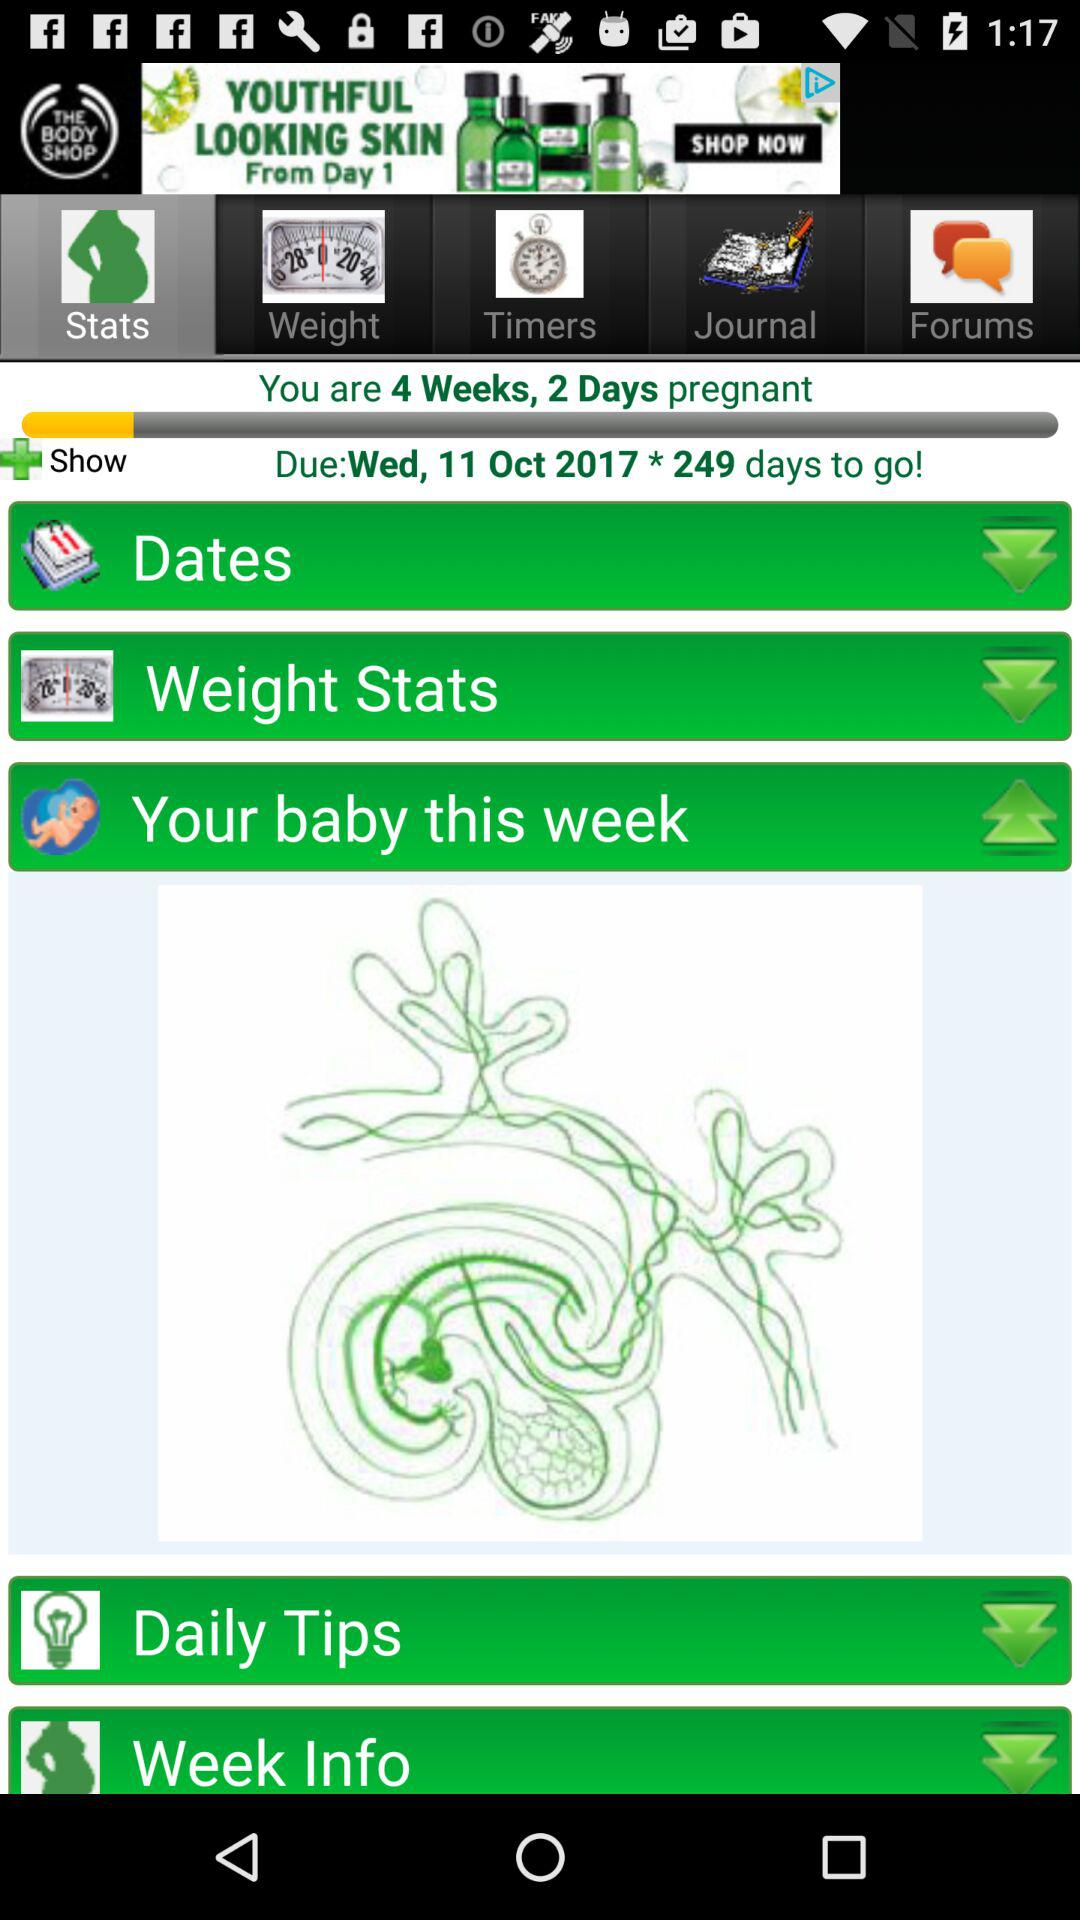Which tab am I on? You are on the "Stats" tab. 